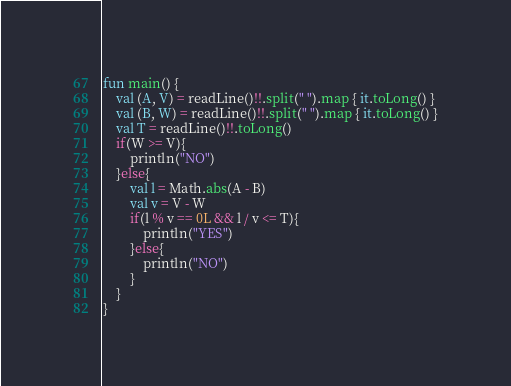Convert code to text. <code><loc_0><loc_0><loc_500><loc_500><_Kotlin_>fun main() {
    val (A, V) = readLine()!!.split(" ").map { it.toLong() }
    val (B, W) = readLine()!!.split(" ").map { it.toLong() }
    val T = readLine()!!.toLong()
    if(W >= V){
        println("NO")
    }else{
        val l = Math.abs(A - B)
        val v = V - W
        if(l % v == 0L && l / v <= T){
            println("YES")
        }else{
            println("NO")
        }
    }
}</code> 